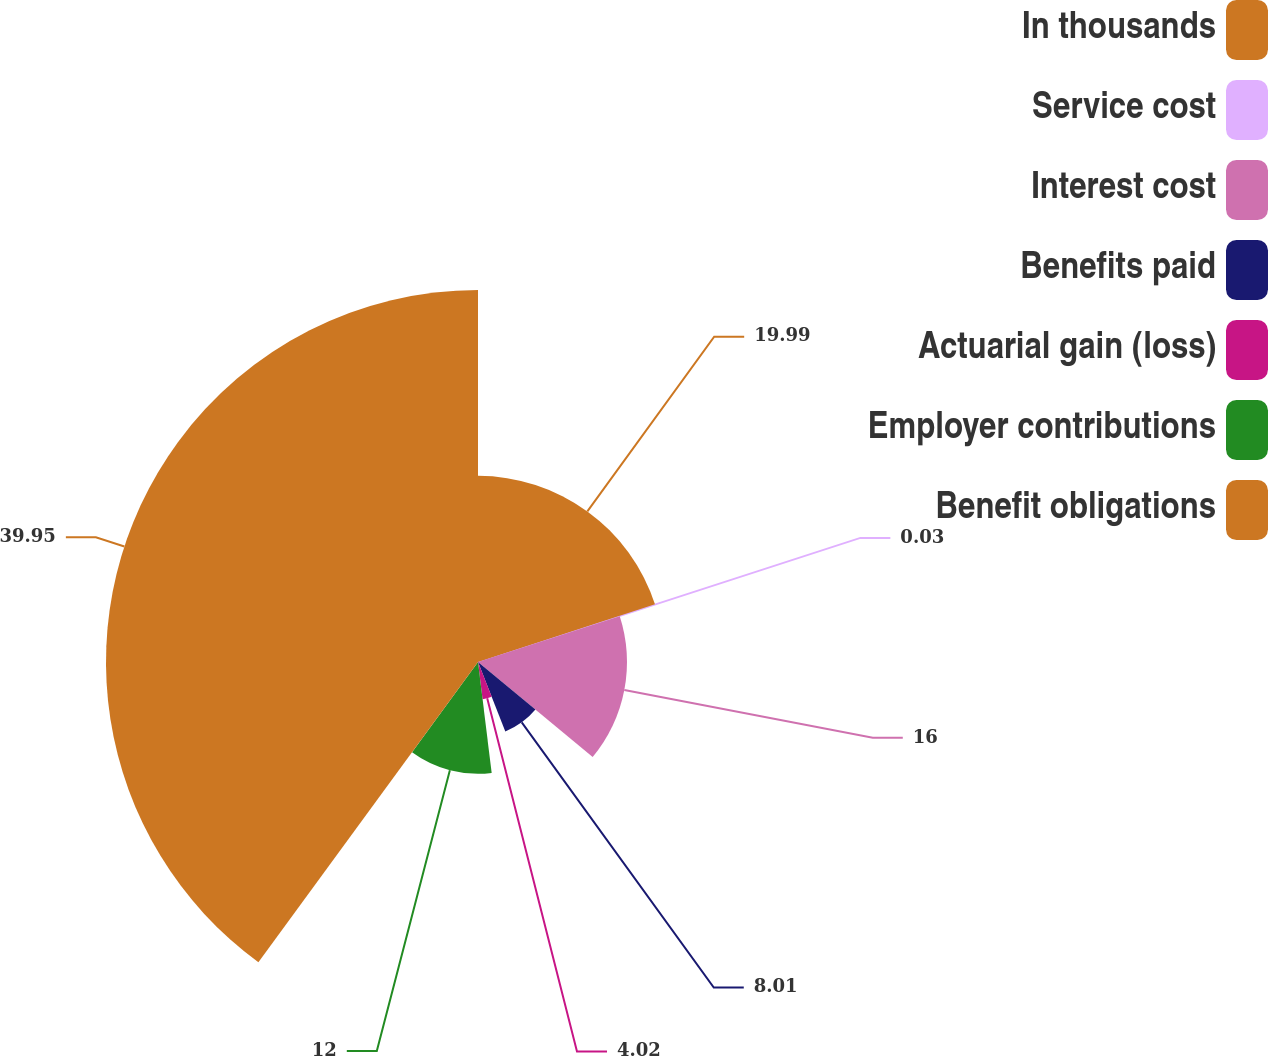Convert chart. <chart><loc_0><loc_0><loc_500><loc_500><pie_chart><fcel>In thousands<fcel>Service cost<fcel>Interest cost<fcel>Benefits paid<fcel>Actuarial gain (loss)<fcel>Employer contributions<fcel>Benefit obligations<nl><fcel>19.99%<fcel>0.03%<fcel>16.0%<fcel>8.01%<fcel>4.02%<fcel>12.0%<fcel>39.95%<nl></chart> 